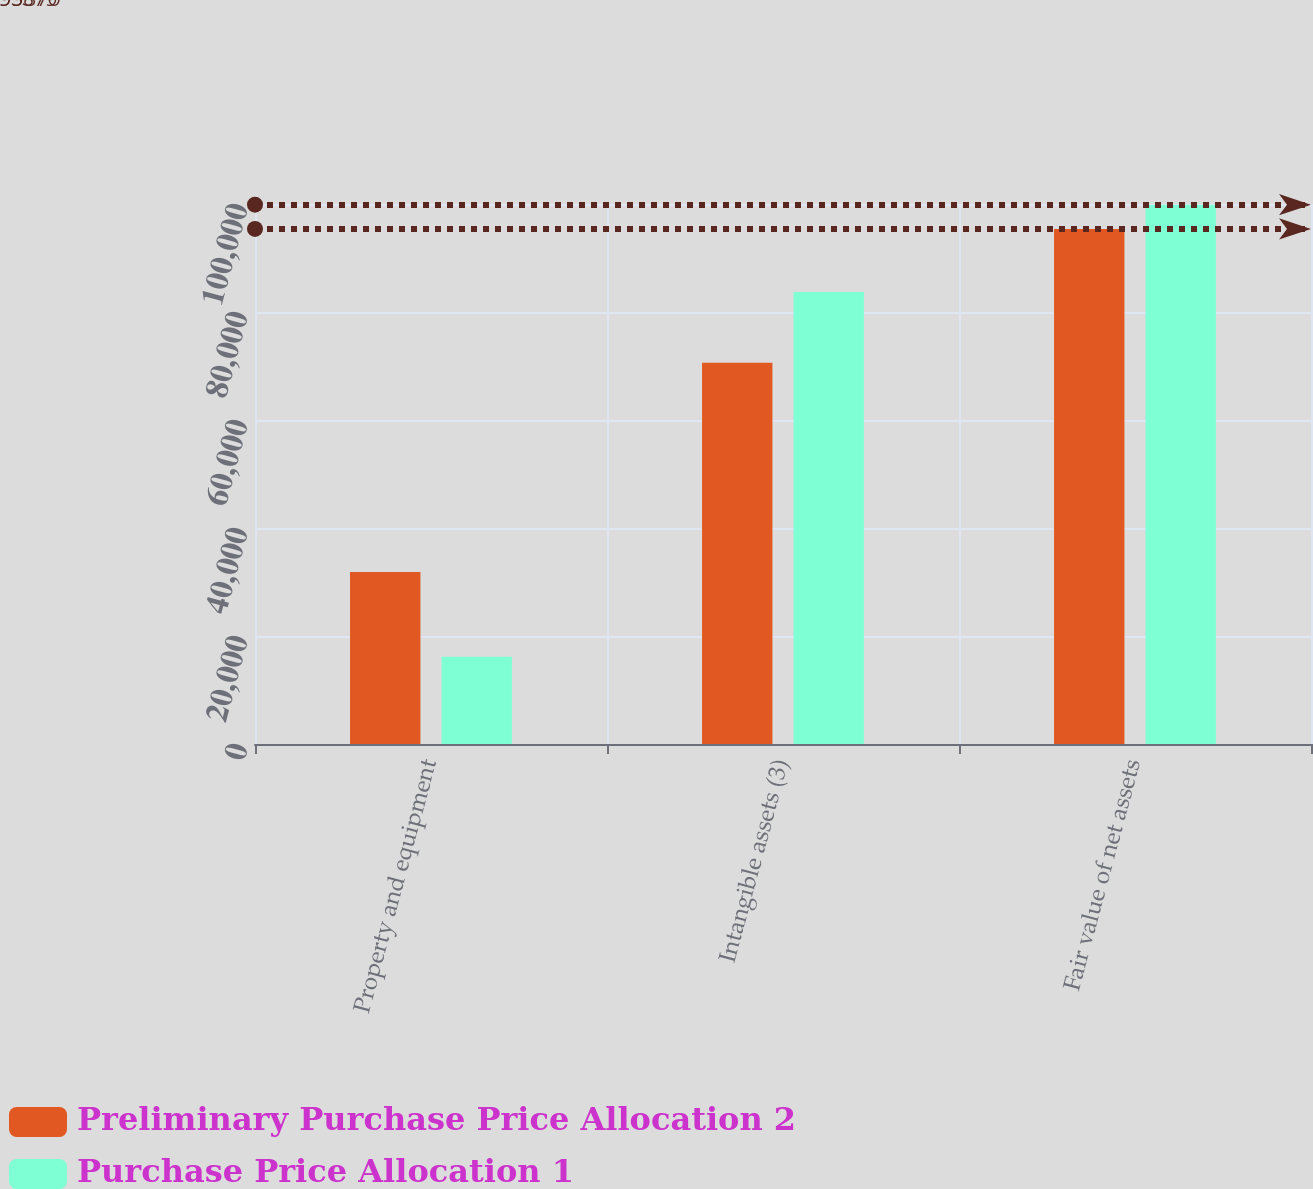Convert chart to OTSL. <chart><loc_0><loc_0><loc_500><loc_500><stacked_bar_chart><ecel><fcel>Property and equipment<fcel>Intangible assets (3)<fcel>Fair value of net assets<nl><fcel>Preliminary Purchase Price Allocation 2<fcel>31850<fcel>70600<fcel>95379<nl><fcel>Purchase Price Allocation 1<fcel>16147<fcel>83723<fcel>99870<nl></chart> 